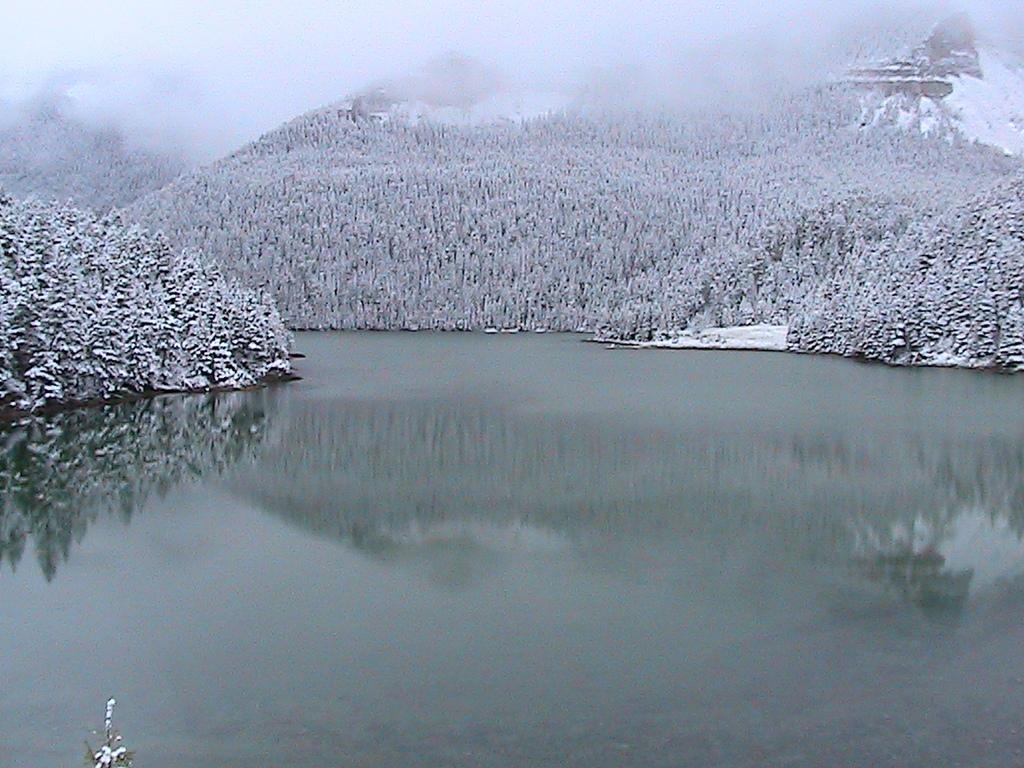Could you give a brief overview of what you see in this image? In this image there is water. Beside there are hills having trees on it which are covered with snow. 